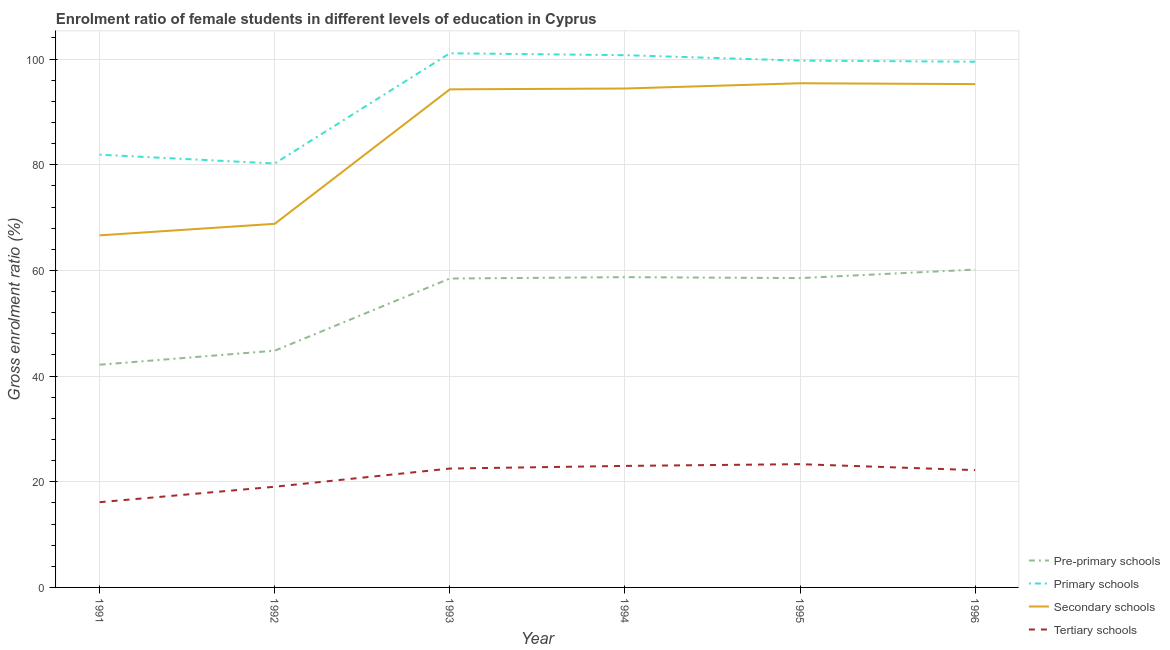Is the number of lines equal to the number of legend labels?
Offer a very short reply. Yes. What is the gross enrolment ratio(male) in pre-primary schools in 1993?
Offer a very short reply. 58.46. Across all years, what is the maximum gross enrolment ratio(male) in tertiary schools?
Give a very brief answer. 23.33. Across all years, what is the minimum gross enrolment ratio(male) in pre-primary schools?
Offer a terse response. 42.15. In which year was the gross enrolment ratio(male) in tertiary schools minimum?
Offer a very short reply. 1991. What is the total gross enrolment ratio(male) in pre-primary schools in the graph?
Offer a very short reply. 322.85. What is the difference between the gross enrolment ratio(male) in secondary schools in 1991 and that in 1992?
Offer a terse response. -2.19. What is the difference between the gross enrolment ratio(male) in primary schools in 1994 and the gross enrolment ratio(male) in secondary schools in 1995?
Your response must be concise. 5.31. What is the average gross enrolment ratio(male) in secondary schools per year?
Offer a very short reply. 85.81. In the year 1995, what is the difference between the gross enrolment ratio(male) in tertiary schools and gross enrolment ratio(male) in secondary schools?
Give a very brief answer. -72.1. In how many years, is the gross enrolment ratio(male) in secondary schools greater than 52 %?
Give a very brief answer. 6. What is the ratio of the gross enrolment ratio(male) in pre-primary schools in 1993 to that in 1996?
Offer a terse response. 0.97. What is the difference between the highest and the second highest gross enrolment ratio(male) in tertiary schools?
Ensure brevity in your answer.  0.33. What is the difference between the highest and the lowest gross enrolment ratio(male) in secondary schools?
Give a very brief answer. 28.79. Is it the case that in every year, the sum of the gross enrolment ratio(male) in pre-primary schools and gross enrolment ratio(male) in primary schools is greater than the gross enrolment ratio(male) in secondary schools?
Your answer should be very brief. Yes. Is the gross enrolment ratio(male) in secondary schools strictly greater than the gross enrolment ratio(male) in pre-primary schools over the years?
Offer a very short reply. Yes. How many years are there in the graph?
Give a very brief answer. 6. What is the difference between two consecutive major ticks on the Y-axis?
Offer a terse response. 20. Does the graph contain grids?
Keep it short and to the point. Yes. How are the legend labels stacked?
Your response must be concise. Vertical. What is the title of the graph?
Provide a succinct answer. Enrolment ratio of female students in different levels of education in Cyprus. Does "UNTA" appear as one of the legend labels in the graph?
Your response must be concise. No. What is the label or title of the X-axis?
Keep it short and to the point. Year. What is the Gross enrolment ratio (%) of Pre-primary schools in 1991?
Offer a very short reply. 42.15. What is the Gross enrolment ratio (%) of Primary schools in 1991?
Your answer should be compact. 81.91. What is the Gross enrolment ratio (%) of Secondary schools in 1991?
Offer a terse response. 66.63. What is the Gross enrolment ratio (%) of Tertiary schools in 1991?
Your answer should be compact. 16.13. What is the Gross enrolment ratio (%) in Pre-primary schools in 1992?
Make the answer very short. 44.8. What is the Gross enrolment ratio (%) of Primary schools in 1992?
Offer a very short reply. 80.24. What is the Gross enrolment ratio (%) in Secondary schools in 1992?
Ensure brevity in your answer.  68.82. What is the Gross enrolment ratio (%) in Tertiary schools in 1992?
Ensure brevity in your answer.  19.06. What is the Gross enrolment ratio (%) in Pre-primary schools in 1993?
Your response must be concise. 58.46. What is the Gross enrolment ratio (%) of Primary schools in 1993?
Provide a short and direct response. 101.1. What is the Gross enrolment ratio (%) in Secondary schools in 1993?
Offer a terse response. 94.27. What is the Gross enrolment ratio (%) in Tertiary schools in 1993?
Offer a terse response. 22.5. What is the Gross enrolment ratio (%) of Pre-primary schools in 1994?
Ensure brevity in your answer.  58.72. What is the Gross enrolment ratio (%) of Primary schools in 1994?
Ensure brevity in your answer.  100.74. What is the Gross enrolment ratio (%) in Secondary schools in 1994?
Ensure brevity in your answer.  94.43. What is the Gross enrolment ratio (%) in Tertiary schools in 1994?
Give a very brief answer. 23. What is the Gross enrolment ratio (%) of Pre-primary schools in 1995?
Give a very brief answer. 58.55. What is the Gross enrolment ratio (%) of Primary schools in 1995?
Provide a short and direct response. 99.71. What is the Gross enrolment ratio (%) of Secondary schools in 1995?
Your response must be concise. 95.43. What is the Gross enrolment ratio (%) in Tertiary schools in 1995?
Ensure brevity in your answer.  23.33. What is the Gross enrolment ratio (%) in Pre-primary schools in 1996?
Your response must be concise. 60.16. What is the Gross enrolment ratio (%) of Primary schools in 1996?
Offer a terse response. 99.5. What is the Gross enrolment ratio (%) in Secondary schools in 1996?
Give a very brief answer. 95.27. What is the Gross enrolment ratio (%) in Tertiary schools in 1996?
Keep it short and to the point. 22.2. Across all years, what is the maximum Gross enrolment ratio (%) in Pre-primary schools?
Your response must be concise. 60.16. Across all years, what is the maximum Gross enrolment ratio (%) in Primary schools?
Your response must be concise. 101.1. Across all years, what is the maximum Gross enrolment ratio (%) in Secondary schools?
Keep it short and to the point. 95.43. Across all years, what is the maximum Gross enrolment ratio (%) of Tertiary schools?
Your response must be concise. 23.33. Across all years, what is the minimum Gross enrolment ratio (%) in Pre-primary schools?
Provide a succinct answer. 42.15. Across all years, what is the minimum Gross enrolment ratio (%) of Primary schools?
Make the answer very short. 80.24. Across all years, what is the minimum Gross enrolment ratio (%) in Secondary schools?
Keep it short and to the point. 66.63. Across all years, what is the minimum Gross enrolment ratio (%) of Tertiary schools?
Ensure brevity in your answer.  16.13. What is the total Gross enrolment ratio (%) of Pre-primary schools in the graph?
Provide a short and direct response. 322.85. What is the total Gross enrolment ratio (%) in Primary schools in the graph?
Your answer should be very brief. 563.19. What is the total Gross enrolment ratio (%) of Secondary schools in the graph?
Your answer should be very brief. 514.84. What is the total Gross enrolment ratio (%) in Tertiary schools in the graph?
Your answer should be compact. 126.22. What is the difference between the Gross enrolment ratio (%) in Pre-primary schools in 1991 and that in 1992?
Keep it short and to the point. -2.65. What is the difference between the Gross enrolment ratio (%) in Primary schools in 1991 and that in 1992?
Make the answer very short. 1.67. What is the difference between the Gross enrolment ratio (%) in Secondary schools in 1991 and that in 1992?
Your answer should be compact. -2.19. What is the difference between the Gross enrolment ratio (%) in Tertiary schools in 1991 and that in 1992?
Your response must be concise. -2.93. What is the difference between the Gross enrolment ratio (%) of Pre-primary schools in 1991 and that in 1993?
Make the answer very short. -16.31. What is the difference between the Gross enrolment ratio (%) in Primary schools in 1991 and that in 1993?
Offer a terse response. -19.19. What is the difference between the Gross enrolment ratio (%) in Secondary schools in 1991 and that in 1993?
Offer a very short reply. -27.64. What is the difference between the Gross enrolment ratio (%) of Tertiary schools in 1991 and that in 1993?
Your response must be concise. -6.37. What is the difference between the Gross enrolment ratio (%) in Pre-primary schools in 1991 and that in 1994?
Provide a short and direct response. -16.57. What is the difference between the Gross enrolment ratio (%) in Primary schools in 1991 and that in 1994?
Make the answer very short. -18.83. What is the difference between the Gross enrolment ratio (%) of Secondary schools in 1991 and that in 1994?
Give a very brief answer. -27.8. What is the difference between the Gross enrolment ratio (%) of Tertiary schools in 1991 and that in 1994?
Your response must be concise. -6.87. What is the difference between the Gross enrolment ratio (%) in Pre-primary schools in 1991 and that in 1995?
Provide a short and direct response. -16.4. What is the difference between the Gross enrolment ratio (%) in Primary schools in 1991 and that in 1995?
Give a very brief answer. -17.8. What is the difference between the Gross enrolment ratio (%) in Secondary schools in 1991 and that in 1995?
Your answer should be compact. -28.79. What is the difference between the Gross enrolment ratio (%) of Tertiary schools in 1991 and that in 1995?
Offer a very short reply. -7.2. What is the difference between the Gross enrolment ratio (%) of Pre-primary schools in 1991 and that in 1996?
Give a very brief answer. -18.01. What is the difference between the Gross enrolment ratio (%) in Primary schools in 1991 and that in 1996?
Provide a succinct answer. -17.59. What is the difference between the Gross enrolment ratio (%) in Secondary schools in 1991 and that in 1996?
Provide a succinct answer. -28.63. What is the difference between the Gross enrolment ratio (%) of Tertiary schools in 1991 and that in 1996?
Ensure brevity in your answer.  -6.07. What is the difference between the Gross enrolment ratio (%) of Pre-primary schools in 1992 and that in 1993?
Offer a very short reply. -13.66. What is the difference between the Gross enrolment ratio (%) in Primary schools in 1992 and that in 1993?
Your response must be concise. -20.86. What is the difference between the Gross enrolment ratio (%) of Secondary schools in 1992 and that in 1993?
Your response must be concise. -25.45. What is the difference between the Gross enrolment ratio (%) of Tertiary schools in 1992 and that in 1993?
Your response must be concise. -3.44. What is the difference between the Gross enrolment ratio (%) of Pre-primary schools in 1992 and that in 1994?
Offer a very short reply. -13.92. What is the difference between the Gross enrolment ratio (%) of Primary schools in 1992 and that in 1994?
Give a very brief answer. -20.5. What is the difference between the Gross enrolment ratio (%) of Secondary schools in 1992 and that in 1994?
Your answer should be very brief. -25.61. What is the difference between the Gross enrolment ratio (%) in Tertiary schools in 1992 and that in 1994?
Your response must be concise. -3.94. What is the difference between the Gross enrolment ratio (%) in Pre-primary schools in 1992 and that in 1995?
Offer a very short reply. -13.74. What is the difference between the Gross enrolment ratio (%) of Primary schools in 1992 and that in 1995?
Your answer should be very brief. -19.48. What is the difference between the Gross enrolment ratio (%) of Secondary schools in 1992 and that in 1995?
Provide a succinct answer. -26.6. What is the difference between the Gross enrolment ratio (%) of Tertiary schools in 1992 and that in 1995?
Provide a short and direct response. -4.27. What is the difference between the Gross enrolment ratio (%) in Pre-primary schools in 1992 and that in 1996?
Your response must be concise. -15.35. What is the difference between the Gross enrolment ratio (%) of Primary schools in 1992 and that in 1996?
Keep it short and to the point. -19.26. What is the difference between the Gross enrolment ratio (%) in Secondary schools in 1992 and that in 1996?
Keep it short and to the point. -26.45. What is the difference between the Gross enrolment ratio (%) in Tertiary schools in 1992 and that in 1996?
Offer a terse response. -3.14. What is the difference between the Gross enrolment ratio (%) of Pre-primary schools in 1993 and that in 1994?
Give a very brief answer. -0.26. What is the difference between the Gross enrolment ratio (%) in Primary schools in 1993 and that in 1994?
Your answer should be very brief. 0.36. What is the difference between the Gross enrolment ratio (%) of Secondary schools in 1993 and that in 1994?
Offer a very short reply. -0.16. What is the difference between the Gross enrolment ratio (%) in Tertiary schools in 1993 and that in 1994?
Provide a succinct answer. -0.5. What is the difference between the Gross enrolment ratio (%) in Pre-primary schools in 1993 and that in 1995?
Your response must be concise. -0.09. What is the difference between the Gross enrolment ratio (%) in Primary schools in 1993 and that in 1995?
Provide a short and direct response. 1.39. What is the difference between the Gross enrolment ratio (%) in Secondary schools in 1993 and that in 1995?
Offer a very short reply. -1.15. What is the difference between the Gross enrolment ratio (%) in Tertiary schools in 1993 and that in 1995?
Your answer should be compact. -0.83. What is the difference between the Gross enrolment ratio (%) of Pre-primary schools in 1993 and that in 1996?
Ensure brevity in your answer.  -1.7. What is the difference between the Gross enrolment ratio (%) of Primary schools in 1993 and that in 1996?
Offer a very short reply. 1.6. What is the difference between the Gross enrolment ratio (%) of Secondary schools in 1993 and that in 1996?
Provide a succinct answer. -0.99. What is the difference between the Gross enrolment ratio (%) of Tertiary schools in 1993 and that in 1996?
Keep it short and to the point. 0.3. What is the difference between the Gross enrolment ratio (%) in Pre-primary schools in 1994 and that in 1995?
Offer a very short reply. 0.18. What is the difference between the Gross enrolment ratio (%) in Primary schools in 1994 and that in 1995?
Ensure brevity in your answer.  1.03. What is the difference between the Gross enrolment ratio (%) of Secondary schools in 1994 and that in 1995?
Your answer should be compact. -1. What is the difference between the Gross enrolment ratio (%) in Tertiary schools in 1994 and that in 1995?
Give a very brief answer. -0.33. What is the difference between the Gross enrolment ratio (%) in Pre-primary schools in 1994 and that in 1996?
Your answer should be very brief. -1.43. What is the difference between the Gross enrolment ratio (%) of Primary schools in 1994 and that in 1996?
Offer a terse response. 1.24. What is the difference between the Gross enrolment ratio (%) in Secondary schools in 1994 and that in 1996?
Make the answer very short. -0.84. What is the difference between the Gross enrolment ratio (%) of Tertiary schools in 1994 and that in 1996?
Ensure brevity in your answer.  0.8. What is the difference between the Gross enrolment ratio (%) in Pre-primary schools in 1995 and that in 1996?
Your answer should be very brief. -1.61. What is the difference between the Gross enrolment ratio (%) of Primary schools in 1995 and that in 1996?
Make the answer very short. 0.21. What is the difference between the Gross enrolment ratio (%) of Secondary schools in 1995 and that in 1996?
Keep it short and to the point. 0.16. What is the difference between the Gross enrolment ratio (%) of Tertiary schools in 1995 and that in 1996?
Keep it short and to the point. 1.13. What is the difference between the Gross enrolment ratio (%) in Pre-primary schools in 1991 and the Gross enrolment ratio (%) in Primary schools in 1992?
Your response must be concise. -38.08. What is the difference between the Gross enrolment ratio (%) of Pre-primary schools in 1991 and the Gross enrolment ratio (%) of Secondary schools in 1992?
Make the answer very short. -26.67. What is the difference between the Gross enrolment ratio (%) of Pre-primary schools in 1991 and the Gross enrolment ratio (%) of Tertiary schools in 1992?
Provide a short and direct response. 23.09. What is the difference between the Gross enrolment ratio (%) of Primary schools in 1991 and the Gross enrolment ratio (%) of Secondary schools in 1992?
Your answer should be very brief. 13.09. What is the difference between the Gross enrolment ratio (%) of Primary schools in 1991 and the Gross enrolment ratio (%) of Tertiary schools in 1992?
Make the answer very short. 62.85. What is the difference between the Gross enrolment ratio (%) of Secondary schools in 1991 and the Gross enrolment ratio (%) of Tertiary schools in 1992?
Ensure brevity in your answer.  47.57. What is the difference between the Gross enrolment ratio (%) in Pre-primary schools in 1991 and the Gross enrolment ratio (%) in Primary schools in 1993?
Your response must be concise. -58.95. What is the difference between the Gross enrolment ratio (%) in Pre-primary schools in 1991 and the Gross enrolment ratio (%) in Secondary schools in 1993?
Your response must be concise. -52.12. What is the difference between the Gross enrolment ratio (%) of Pre-primary schools in 1991 and the Gross enrolment ratio (%) of Tertiary schools in 1993?
Your answer should be very brief. 19.65. What is the difference between the Gross enrolment ratio (%) of Primary schools in 1991 and the Gross enrolment ratio (%) of Secondary schools in 1993?
Make the answer very short. -12.37. What is the difference between the Gross enrolment ratio (%) of Primary schools in 1991 and the Gross enrolment ratio (%) of Tertiary schools in 1993?
Your answer should be very brief. 59.41. What is the difference between the Gross enrolment ratio (%) of Secondary schools in 1991 and the Gross enrolment ratio (%) of Tertiary schools in 1993?
Your answer should be very brief. 44.13. What is the difference between the Gross enrolment ratio (%) in Pre-primary schools in 1991 and the Gross enrolment ratio (%) in Primary schools in 1994?
Give a very brief answer. -58.59. What is the difference between the Gross enrolment ratio (%) of Pre-primary schools in 1991 and the Gross enrolment ratio (%) of Secondary schools in 1994?
Ensure brevity in your answer.  -52.28. What is the difference between the Gross enrolment ratio (%) of Pre-primary schools in 1991 and the Gross enrolment ratio (%) of Tertiary schools in 1994?
Provide a succinct answer. 19.15. What is the difference between the Gross enrolment ratio (%) in Primary schools in 1991 and the Gross enrolment ratio (%) in Secondary schools in 1994?
Your answer should be compact. -12.52. What is the difference between the Gross enrolment ratio (%) in Primary schools in 1991 and the Gross enrolment ratio (%) in Tertiary schools in 1994?
Your answer should be very brief. 58.91. What is the difference between the Gross enrolment ratio (%) in Secondary schools in 1991 and the Gross enrolment ratio (%) in Tertiary schools in 1994?
Offer a very short reply. 43.63. What is the difference between the Gross enrolment ratio (%) in Pre-primary schools in 1991 and the Gross enrolment ratio (%) in Primary schools in 1995?
Ensure brevity in your answer.  -57.56. What is the difference between the Gross enrolment ratio (%) of Pre-primary schools in 1991 and the Gross enrolment ratio (%) of Secondary schools in 1995?
Offer a terse response. -53.27. What is the difference between the Gross enrolment ratio (%) in Pre-primary schools in 1991 and the Gross enrolment ratio (%) in Tertiary schools in 1995?
Offer a very short reply. 18.82. What is the difference between the Gross enrolment ratio (%) of Primary schools in 1991 and the Gross enrolment ratio (%) of Secondary schools in 1995?
Offer a terse response. -13.52. What is the difference between the Gross enrolment ratio (%) in Primary schools in 1991 and the Gross enrolment ratio (%) in Tertiary schools in 1995?
Provide a succinct answer. 58.58. What is the difference between the Gross enrolment ratio (%) of Secondary schools in 1991 and the Gross enrolment ratio (%) of Tertiary schools in 1995?
Make the answer very short. 43.3. What is the difference between the Gross enrolment ratio (%) in Pre-primary schools in 1991 and the Gross enrolment ratio (%) in Primary schools in 1996?
Give a very brief answer. -57.35. What is the difference between the Gross enrolment ratio (%) of Pre-primary schools in 1991 and the Gross enrolment ratio (%) of Secondary schools in 1996?
Your answer should be very brief. -53.11. What is the difference between the Gross enrolment ratio (%) in Pre-primary schools in 1991 and the Gross enrolment ratio (%) in Tertiary schools in 1996?
Ensure brevity in your answer.  19.95. What is the difference between the Gross enrolment ratio (%) in Primary schools in 1991 and the Gross enrolment ratio (%) in Secondary schools in 1996?
Offer a terse response. -13.36. What is the difference between the Gross enrolment ratio (%) in Primary schools in 1991 and the Gross enrolment ratio (%) in Tertiary schools in 1996?
Make the answer very short. 59.7. What is the difference between the Gross enrolment ratio (%) of Secondary schools in 1991 and the Gross enrolment ratio (%) of Tertiary schools in 1996?
Give a very brief answer. 44.43. What is the difference between the Gross enrolment ratio (%) in Pre-primary schools in 1992 and the Gross enrolment ratio (%) in Primary schools in 1993?
Your answer should be compact. -56.29. What is the difference between the Gross enrolment ratio (%) of Pre-primary schools in 1992 and the Gross enrolment ratio (%) of Secondary schools in 1993?
Provide a short and direct response. -49.47. What is the difference between the Gross enrolment ratio (%) in Pre-primary schools in 1992 and the Gross enrolment ratio (%) in Tertiary schools in 1993?
Provide a short and direct response. 22.31. What is the difference between the Gross enrolment ratio (%) in Primary schools in 1992 and the Gross enrolment ratio (%) in Secondary schools in 1993?
Your answer should be compact. -14.04. What is the difference between the Gross enrolment ratio (%) in Primary schools in 1992 and the Gross enrolment ratio (%) in Tertiary schools in 1993?
Offer a very short reply. 57.74. What is the difference between the Gross enrolment ratio (%) of Secondary schools in 1992 and the Gross enrolment ratio (%) of Tertiary schools in 1993?
Your answer should be compact. 46.32. What is the difference between the Gross enrolment ratio (%) in Pre-primary schools in 1992 and the Gross enrolment ratio (%) in Primary schools in 1994?
Offer a terse response. -55.93. What is the difference between the Gross enrolment ratio (%) in Pre-primary schools in 1992 and the Gross enrolment ratio (%) in Secondary schools in 1994?
Your response must be concise. -49.62. What is the difference between the Gross enrolment ratio (%) of Pre-primary schools in 1992 and the Gross enrolment ratio (%) of Tertiary schools in 1994?
Offer a very short reply. 21.81. What is the difference between the Gross enrolment ratio (%) in Primary schools in 1992 and the Gross enrolment ratio (%) in Secondary schools in 1994?
Make the answer very short. -14.19. What is the difference between the Gross enrolment ratio (%) of Primary schools in 1992 and the Gross enrolment ratio (%) of Tertiary schools in 1994?
Give a very brief answer. 57.24. What is the difference between the Gross enrolment ratio (%) of Secondary schools in 1992 and the Gross enrolment ratio (%) of Tertiary schools in 1994?
Provide a succinct answer. 45.82. What is the difference between the Gross enrolment ratio (%) of Pre-primary schools in 1992 and the Gross enrolment ratio (%) of Primary schools in 1995?
Your answer should be very brief. -54.91. What is the difference between the Gross enrolment ratio (%) in Pre-primary schools in 1992 and the Gross enrolment ratio (%) in Secondary schools in 1995?
Offer a very short reply. -50.62. What is the difference between the Gross enrolment ratio (%) of Pre-primary schools in 1992 and the Gross enrolment ratio (%) of Tertiary schools in 1995?
Provide a short and direct response. 21.48. What is the difference between the Gross enrolment ratio (%) of Primary schools in 1992 and the Gross enrolment ratio (%) of Secondary schools in 1995?
Make the answer very short. -15.19. What is the difference between the Gross enrolment ratio (%) of Primary schools in 1992 and the Gross enrolment ratio (%) of Tertiary schools in 1995?
Your answer should be very brief. 56.91. What is the difference between the Gross enrolment ratio (%) in Secondary schools in 1992 and the Gross enrolment ratio (%) in Tertiary schools in 1995?
Ensure brevity in your answer.  45.49. What is the difference between the Gross enrolment ratio (%) in Pre-primary schools in 1992 and the Gross enrolment ratio (%) in Primary schools in 1996?
Your answer should be very brief. -54.69. What is the difference between the Gross enrolment ratio (%) of Pre-primary schools in 1992 and the Gross enrolment ratio (%) of Secondary schools in 1996?
Your response must be concise. -50.46. What is the difference between the Gross enrolment ratio (%) in Pre-primary schools in 1992 and the Gross enrolment ratio (%) in Tertiary schools in 1996?
Keep it short and to the point. 22.6. What is the difference between the Gross enrolment ratio (%) of Primary schools in 1992 and the Gross enrolment ratio (%) of Secondary schools in 1996?
Offer a very short reply. -15.03. What is the difference between the Gross enrolment ratio (%) of Primary schools in 1992 and the Gross enrolment ratio (%) of Tertiary schools in 1996?
Make the answer very short. 58.03. What is the difference between the Gross enrolment ratio (%) in Secondary schools in 1992 and the Gross enrolment ratio (%) in Tertiary schools in 1996?
Offer a terse response. 46.62. What is the difference between the Gross enrolment ratio (%) of Pre-primary schools in 1993 and the Gross enrolment ratio (%) of Primary schools in 1994?
Provide a succinct answer. -42.28. What is the difference between the Gross enrolment ratio (%) of Pre-primary schools in 1993 and the Gross enrolment ratio (%) of Secondary schools in 1994?
Make the answer very short. -35.97. What is the difference between the Gross enrolment ratio (%) in Pre-primary schools in 1993 and the Gross enrolment ratio (%) in Tertiary schools in 1994?
Give a very brief answer. 35.46. What is the difference between the Gross enrolment ratio (%) in Primary schools in 1993 and the Gross enrolment ratio (%) in Secondary schools in 1994?
Ensure brevity in your answer.  6.67. What is the difference between the Gross enrolment ratio (%) of Primary schools in 1993 and the Gross enrolment ratio (%) of Tertiary schools in 1994?
Ensure brevity in your answer.  78.1. What is the difference between the Gross enrolment ratio (%) in Secondary schools in 1993 and the Gross enrolment ratio (%) in Tertiary schools in 1994?
Make the answer very short. 71.27. What is the difference between the Gross enrolment ratio (%) in Pre-primary schools in 1993 and the Gross enrolment ratio (%) in Primary schools in 1995?
Your response must be concise. -41.25. What is the difference between the Gross enrolment ratio (%) of Pre-primary schools in 1993 and the Gross enrolment ratio (%) of Secondary schools in 1995?
Offer a very short reply. -36.96. What is the difference between the Gross enrolment ratio (%) of Pre-primary schools in 1993 and the Gross enrolment ratio (%) of Tertiary schools in 1995?
Provide a short and direct response. 35.13. What is the difference between the Gross enrolment ratio (%) of Primary schools in 1993 and the Gross enrolment ratio (%) of Secondary schools in 1995?
Make the answer very short. 5.67. What is the difference between the Gross enrolment ratio (%) in Primary schools in 1993 and the Gross enrolment ratio (%) in Tertiary schools in 1995?
Provide a short and direct response. 77.77. What is the difference between the Gross enrolment ratio (%) of Secondary schools in 1993 and the Gross enrolment ratio (%) of Tertiary schools in 1995?
Offer a terse response. 70.94. What is the difference between the Gross enrolment ratio (%) of Pre-primary schools in 1993 and the Gross enrolment ratio (%) of Primary schools in 1996?
Your answer should be very brief. -41.04. What is the difference between the Gross enrolment ratio (%) of Pre-primary schools in 1993 and the Gross enrolment ratio (%) of Secondary schools in 1996?
Offer a terse response. -36.8. What is the difference between the Gross enrolment ratio (%) in Pre-primary schools in 1993 and the Gross enrolment ratio (%) in Tertiary schools in 1996?
Make the answer very short. 36.26. What is the difference between the Gross enrolment ratio (%) of Primary schools in 1993 and the Gross enrolment ratio (%) of Secondary schools in 1996?
Make the answer very short. 5.83. What is the difference between the Gross enrolment ratio (%) in Primary schools in 1993 and the Gross enrolment ratio (%) in Tertiary schools in 1996?
Offer a terse response. 78.9. What is the difference between the Gross enrolment ratio (%) in Secondary schools in 1993 and the Gross enrolment ratio (%) in Tertiary schools in 1996?
Keep it short and to the point. 72.07. What is the difference between the Gross enrolment ratio (%) in Pre-primary schools in 1994 and the Gross enrolment ratio (%) in Primary schools in 1995?
Keep it short and to the point. -40.99. What is the difference between the Gross enrolment ratio (%) in Pre-primary schools in 1994 and the Gross enrolment ratio (%) in Secondary schools in 1995?
Your answer should be compact. -36.7. What is the difference between the Gross enrolment ratio (%) in Pre-primary schools in 1994 and the Gross enrolment ratio (%) in Tertiary schools in 1995?
Give a very brief answer. 35.4. What is the difference between the Gross enrolment ratio (%) of Primary schools in 1994 and the Gross enrolment ratio (%) of Secondary schools in 1995?
Provide a succinct answer. 5.31. What is the difference between the Gross enrolment ratio (%) of Primary schools in 1994 and the Gross enrolment ratio (%) of Tertiary schools in 1995?
Offer a terse response. 77.41. What is the difference between the Gross enrolment ratio (%) of Secondary schools in 1994 and the Gross enrolment ratio (%) of Tertiary schools in 1995?
Your answer should be compact. 71.1. What is the difference between the Gross enrolment ratio (%) in Pre-primary schools in 1994 and the Gross enrolment ratio (%) in Primary schools in 1996?
Make the answer very short. -40.77. What is the difference between the Gross enrolment ratio (%) of Pre-primary schools in 1994 and the Gross enrolment ratio (%) of Secondary schools in 1996?
Provide a succinct answer. -36.54. What is the difference between the Gross enrolment ratio (%) in Pre-primary schools in 1994 and the Gross enrolment ratio (%) in Tertiary schools in 1996?
Offer a very short reply. 36.52. What is the difference between the Gross enrolment ratio (%) in Primary schools in 1994 and the Gross enrolment ratio (%) in Secondary schools in 1996?
Your response must be concise. 5.47. What is the difference between the Gross enrolment ratio (%) of Primary schools in 1994 and the Gross enrolment ratio (%) of Tertiary schools in 1996?
Offer a terse response. 78.54. What is the difference between the Gross enrolment ratio (%) in Secondary schools in 1994 and the Gross enrolment ratio (%) in Tertiary schools in 1996?
Your answer should be very brief. 72.23. What is the difference between the Gross enrolment ratio (%) in Pre-primary schools in 1995 and the Gross enrolment ratio (%) in Primary schools in 1996?
Offer a terse response. -40.95. What is the difference between the Gross enrolment ratio (%) of Pre-primary schools in 1995 and the Gross enrolment ratio (%) of Secondary schools in 1996?
Your response must be concise. -36.72. What is the difference between the Gross enrolment ratio (%) in Pre-primary schools in 1995 and the Gross enrolment ratio (%) in Tertiary schools in 1996?
Keep it short and to the point. 36.35. What is the difference between the Gross enrolment ratio (%) in Primary schools in 1995 and the Gross enrolment ratio (%) in Secondary schools in 1996?
Your answer should be very brief. 4.45. What is the difference between the Gross enrolment ratio (%) in Primary schools in 1995 and the Gross enrolment ratio (%) in Tertiary schools in 1996?
Your answer should be very brief. 77.51. What is the difference between the Gross enrolment ratio (%) in Secondary schools in 1995 and the Gross enrolment ratio (%) in Tertiary schools in 1996?
Provide a succinct answer. 73.22. What is the average Gross enrolment ratio (%) in Pre-primary schools per year?
Provide a succinct answer. 53.81. What is the average Gross enrolment ratio (%) in Primary schools per year?
Offer a very short reply. 93.86. What is the average Gross enrolment ratio (%) of Secondary schools per year?
Offer a terse response. 85.81. What is the average Gross enrolment ratio (%) of Tertiary schools per year?
Your response must be concise. 21.04. In the year 1991, what is the difference between the Gross enrolment ratio (%) of Pre-primary schools and Gross enrolment ratio (%) of Primary schools?
Your answer should be compact. -39.76. In the year 1991, what is the difference between the Gross enrolment ratio (%) in Pre-primary schools and Gross enrolment ratio (%) in Secondary schools?
Your response must be concise. -24.48. In the year 1991, what is the difference between the Gross enrolment ratio (%) of Pre-primary schools and Gross enrolment ratio (%) of Tertiary schools?
Provide a succinct answer. 26.02. In the year 1991, what is the difference between the Gross enrolment ratio (%) of Primary schools and Gross enrolment ratio (%) of Secondary schools?
Make the answer very short. 15.27. In the year 1991, what is the difference between the Gross enrolment ratio (%) in Primary schools and Gross enrolment ratio (%) in Tertiary schools?
Ensure brevity in your answer.  65.77. In the year 1991, what is the difference between the Gross enrolment ratio (%) in Secondary schools and Gross enrolment ratio (%) in Tertiary schools?
Offer a very short reply. 50.5. In the year 1992, what is the difference between the Gross enrolment ratio (%) in Pre-primary schools and Gross enrolment ratio (%) in Primary schools?
Ensure brevity in your answer.  -35.43. In the year 1992, what is the difference between the Gross enrolment ratio (%) in Pre-primary schools and Gross enrolment ratio (%) in Secondary schools?
Your answer should be compact. -24.02. In the year 1992, what is the difference between the Gross enrolment ratio (%) in Pre-primary schools and Gross enrolment ratio (%) in Tertiary schools?
Offer a very short reply. 25.75. In the year 1992, what is the difference between the Gross enrolment ratio (%) of Primary schools and Gross enrolment ratio (%) of Secondary schools?
Provide a succinct answer. 11.41. In the year 1992, what is the difference between the Gross enrolment ratio (%) in Primary schools and Gross enrolment ratio (%) in Tertiary schools?
Offer a very short reply. 61.18. In the year 1992, what is the difference between the Gross enrolment ratio (%) of Secondary schools and Gross enrolment ratio (%) of Tertiary schools?
Offer a very short reply. 49.76. In the year 1993, what is the difference between the Gross enrolment ratio (%) in Pre-primary schools and Gross enrolment ratio (%) in Primary schools?
Your answer should be compact. -42.64. In the year 1993, what is the difference between the Gross enrolment ratio (%) in Pre-primary schools and Gross enrolment ratio (%) in Secondary schools?
Provide a succinct answer. -35.81. In the year 1993, what is the difference between the Gross enrolment ratio (%) of Pre-primary schools and Gross enrolment ratio (%) of Tertiary schools?
Make the answer very short. 35.96. In the year 1993, what is the difference between the Gross enrolment ratio (%) in Primary schools and Gross enrolment ratio (%) in Secondary schools?
Ensure brevity in your answer.  6.83. In the year 1993, what is the difference between the Gross enrolment ratio (%) of Primary schools and Gross enrolment ratio (%) of Tertiary schools?
Your answer should be very brief. 78.6. In the year 1993, what is the difference between the Gross enrolment ratio (%) of Secondary schools and Gross enrolment ratio (%) of Tertiary schools?
Your response must be concise. 71.77. In the year 1994, what is the difference between the Gross enrolment ratio (%) of Pre-primary schools and Gross enrolment ratio (%) of Primary schools?
Your response must be concise. -42.01. In the year 1994, what is the difference between the Gross enrolment ratio (%) in Pre-primary schools and Gross enrolment ratio (%) in Secondary schools?
Your answer should be very brief. -35.7. In the year 1994, what is the difference between the Gross enrolment ratio (%) in Pre-primary schools and Gross enrolment ratio (%) in Tertiary schools?
Provide a succinct answer. 35.72. In the year 1994, what is the difference between the Gross enrolment ratio (%) of Primary schools and Gross enrolment ratio (%) of Secondary schools?
Offer a very short reply. 6.31. In the year 1994, what is the difference between the Gross enrolment ratio (%) in Primary schools and Gross enrolment ratio (%) in Tertiary schools?
Provide a short and direct response. 77.74. In the year 1994, what is the difference between the Gross enrolment ratio (%) of Secondary schools and Gross enrolment ratio (%) of Tertiary schools?
Make the answer very short. 71.43. In the year 1995, what is the difference between the Gross enrolment ratio (%) in Pre-primary schools and Gross enrolment ratio (%) in Primary schools?
Provide a succinct answer. -41.16. In the year 1995, what is the difference between the Gross enrolment ratio (%) in Pre-primary schools and Gross enrolment ratio (%) in Secondary schools?
Give a very brief answer. -36.88. In the year 1995, what is the difference between the Gross enrolment ratio (%) in Pre-primary schools and Gross enrolment ratio (%) in Tertiary schools?
Ensure brevity in your answer.  35.22. In the year 1995, what is the difference between the Gross enrolment ratio (%) of Primary schools and Gross enrolment ratio (%) of Secondary schools?
Your response must be concise. 4.29. In the year 1995, what is the difference between the Gross enrolment ratio (%) of Primary schools and Gross enrolment ratio (%) of Tertiary schools?
Give a very brief answer. 76.38. In the year 1995, what is the difference between the Gross enrolment ratio (%) of Secondary schools and Gross enrolment ratio (%) of Tertiary schools?
Provide a short and direct response. 72.1. In the year 1996, what is the difference between the Gross enrolment ratio (%) in Pre-primary schools and Gross enrolment ratio (%) in Primary schools?
Make the answer very short. -39.34. In the year 1996, what is the difference between the Gross enrolment ratio (%) of Pre-primary schools and Gross enrolment ratio (%) of Secondary schools?
Your answer should be very brief. -35.11. In the year 1996, what is the difference between the Gross enrolment ratio (%) in Pre-primary schools and Gross enrolment ratio (%) in Tertiary schools?
Offer a very short reply. 37.96. In the year 1996, what is the difference between the Gross enrolment ratio (%) in Primary schools and Gross enrolment ratio (%) in Secondary schools?
Your answer should be very brief. 4.23. In the year 1996, what is the difference between the Gross enrolment ratio (%) of Primary schools and Gross enrolment ratio (%) of Tertiary schools?
Your answer should be compact. 77.3. In the year 1996, what is the difference between the Gross enrolment ratio (%) in Secondary schools and Gross enrolment ratio (%) in Tertiary schools?
Provide a short and direct response. 73.06. What is the ratio of the Gross enrolment ratio (%) in Pre-primary schools in 1991 to that in 1992?
Keep it short and to the point. 0.94. What is the ratio of the Gross enrolment ratio (%) in Primary schools in 1991 to that in 1992?
Your answer should be very brief. 1.02. What is the ratio of the Gross enrolment ratio (%) of Secondary schools in 1991 to that in 1992?
Provide a succinct answer. 0.97. What is the ratio of the Gross enrolment ratio (%) in Tertiary schools in 1991 to that in 1992?
Your answer should be very brief. 0.85. What is the ratio of the Gross enrolment ratio (%) in Pre-primary schools in 1991 to that in 1993?
Provide a short and direct response. 0.72. What is the ratio of the Gross enrolment ratio (%) in Primary schools in 1991 to that in 1993?
Your answer should be very brief. 0.81. What is the ratio of the Gross enrolment ratio (%) of Secondary schools in 1991 to that in 1993?
Provide a short and direct response. 0.71. What is the ratio of the Gross enrolment ratio (%) of Tertiary schools in 1991 to that in 1993?
Keep it short and to the point. 0.72. What is the ratio of the Gross enrolment ratio (%) of Pre-primary schools in 1991 to that in 1994?
Give a very brief answer. 0.72. What is the ratio of the Gross enrolment ratio (%) of Primary schools in 1991 to that in 1994?
Your answer should be very brief. 0.81. What is the ratio of the Gross enrolment ratio (%) in Secondary schools in 1991 to that in 1994?
Make the answer very short. 0.71. What is the ratio of the Gross enrolment ratio (%) in Tertiary schools in 1991 to that in 1994?
Make the answer very short. 0.7. What is the ratio of the Gross enrolment ratio (%) of Pre-primary schools in 1991 to that in 1995?
Make the answer very short. 0.72. What is the ratio of the Gross enrolment ratio (%) of Primary schools in 1991 to that in 1995?
Your response must be concise. 0.82. What is the ratio of the Gross enrolment ratio (%) in Secondary schools in 1991 to that in 1995?
Ensure brevity in your answer.  0.7. What is the ratio of the Gross enrolment ratio (%) of Tertiary schools in 1991 to that in 1995?
Make the answer very short. 0.69. What is the ratio of the Gross enrolment ratio (%) of Pre-primary schools in 1991 to that in 1996?
Your answer should be very brief. 0.7. What is the ratio of the Gross enrolment ratio (%) of Primary schools in 1991 to that in 1996?
Provide a short and direct response. 0.82. What is the ratio of the Gross enrolment ratio (%) in Secondary schools in 1991 to that in 1996?
Your answer should be very brief. 0.7. What is the ratio of the Gross enrolment ratio (%) in Tertiary schools in 1991 to that in 1996?
Your response must be concise. 0.73. What is the ratio of the Gross enrolment ratio (%) of Pre-primary schools in 1992 to that in 1993?
Your answer should be compact. 0.77. What is the ratio of the Gross enrolment ratio (%) in Primary schools in 1992 to that in 1993?
Ensure brevity in your answer.  0.79. What is the ratio of the Gross enrolment ratio (%) of Secondary schools in 1992 to that in 1993?
Keep it short and to the point. 0.73. What is the ratio of the Gross enrolment ratio (%) of Tertiary schools in 1992 to that in 1993?
Make the answer very short. 0.85. What is the ratio of the Gross enrolment ratio (%) of Pre-primary schools in 1992 to that in 1994?
Keep it short and to the point. 0.76. What is the ratio of the Gross enrolment ratio (%) of Primary schools in 1992 to that in 1994?
Offer a terse response. 0.8. What is the ratio of the Gross enrolment ratio (%) of Secondary schools in 1992 to that in 1994?
Your answer should be compact. 0.73. What is the ratio of the Gross enrolment ratio (%) of Tertiary schools in 1992 to that in 1994?
Keep it short and to the point. 0.83. What is the ratio of the Gross enrolment ratio (%) of Pre-primary schools in 1992 to that in 1995?
Give a very brief answer. 0.77. What is the ratio of the Gross enrolment ratio (%) in Primary schools in 1992 to that in 1995?
Make the answer very short. 0.8. What is the ratio of the Gross enrolment ratio (%) in Secondary schools in 1992 to that in 1995?
Your answer should be compact. 0.72. What is the ratio of the Gross enrolment ratio (%) in Tertiary schools in 1992 to that in 1995?
Ensure brevity in your answer.  0.82. What is the ratio of the Gross enrolment ratio (%) of Pre-primary schools in 1992 to that in 1996?
Give a very brief answer. 0.74. What is the ratio of the Gross enrolment ratio (%) of Primary schools in 1992 to that in 1996?
Provide a succinct answer. 0.81. What is the ratio of the Gross enrolment ratio (%) of Secondary schools in 1992 to that in 1996?
Offer a terse response. 0.72. What is the ratio of the Gross enrolment ratio (%) of Tertiary schools in 1992 to that in 1996?
Offer a very short reply. 0.86. What is the ratio of the Gross enrolment ratio (%) in Tertiary schools in 1993 to that in 1994?
Make the answer very short. 0.98. What is the ratio of the Gross enrolment ratio (%) of Primary schools in 1993 to that in 1995?
Offer a terse response. 1.01. What is the ratio of the Gross enrolment ratio (%) in Secondary schools in 1993 to that in 1995?
Provide a short and direct response. 0.99. What is the ratio of the Gross enrolment ratio (%) of Tertiary schools in 1993 to that in 1995?
Provide a succinct answer. 0.96. What is the ratio of the Gross enrolment ratio (%) in Pre-primary schools in 1993 to that in 1996?
Offer a very short reply. 0.97. What is the ratio of the Gross enrolment ratio (%) in Primary schools in 1993 to that in 1996?
Your answer should be very brief. 1.02. What is the ratio of the Gross enrolment ratio (%) of Tertiary schools in 1993 to that in 1996?
Offer a terse response. 1.01. What is the ratio of the Gross enrolment ratio (%) of Pre-primary schools in 1994 to that in 1995?
Offer a terse response. 1. What is the ratio of the Gross enrolment ratio (%) in Primary schools in 1994 to that in 1995?
Your answer should be compact. 1.01. What is the ratio of the Gross enrolment ratio (%) in Tertiary schools in 1994 to that in 1995?
Your answer should be very brief. 0.99. What is the ratio of the Gross enrolment ratio (%) of Pre-primary schools in 1994 to that in 1996?
Keep it short and to the point. 0.98. What is the ratio of the Gross enrolment ratio (%) of Primary schools in 1994 to that in 1996?
Provide a short and direct response. 1.01. What is the ratio of the Gross enrolment ratio (%) of Tertiary schools in 1994 to that in 1996?
Provide a succinct answer. 1.04. What is the ratio of the Gross enrolment ratio (%) in Pre-primary schools in 1995 to that in 1996?
Your response must be concise. 0.97. What is the ratio of the Gross enrolment ratio (%) in Primary schools in 1995 to that in 1996?
Your response must be concise. 1. What is the ratio of the Gross enrolment ratio (%) in Tertiary schools in 1995 to that in 1996?
Your response must be concise. 1.05. What is the difference between the highest and the second highest Gross enrolment ratio (%) in Pre-primary schools?
Your answer should be compact. 1.43. What is the difference between the highest and the second highest Gross enrolment ratio (%) of Primary schools?
Give a very brief answer. 0.36. What is the difference between the highest and the second highest Gross enrolment ratio (%) of Secondary schools?
Offer a terse response. 0.16. What is the difference between the highest and the second highest Gross enrolment ratio (%) in Tertiary schools?
Provide a short and direct response. 0.33. What is the difference between the highest and the lowest Gross enrolment ratio (%) of Pre-primary schools?
Offer a very short reply. 18.01. What is the difference between the highest and the lowest Gross enrolment ratio (%) in Primary schools?
Provide a short and direct response. 20.86. What is the difference between the highest and the lowest Gross enrolment ratio (%) in Secondary schools?
Your answer should be compact. 28.79. What is the difference between the highest and the lowest Gross enrolment ratio (%) in Tertiary schools?
Provide a short and direct response. 7.2. 